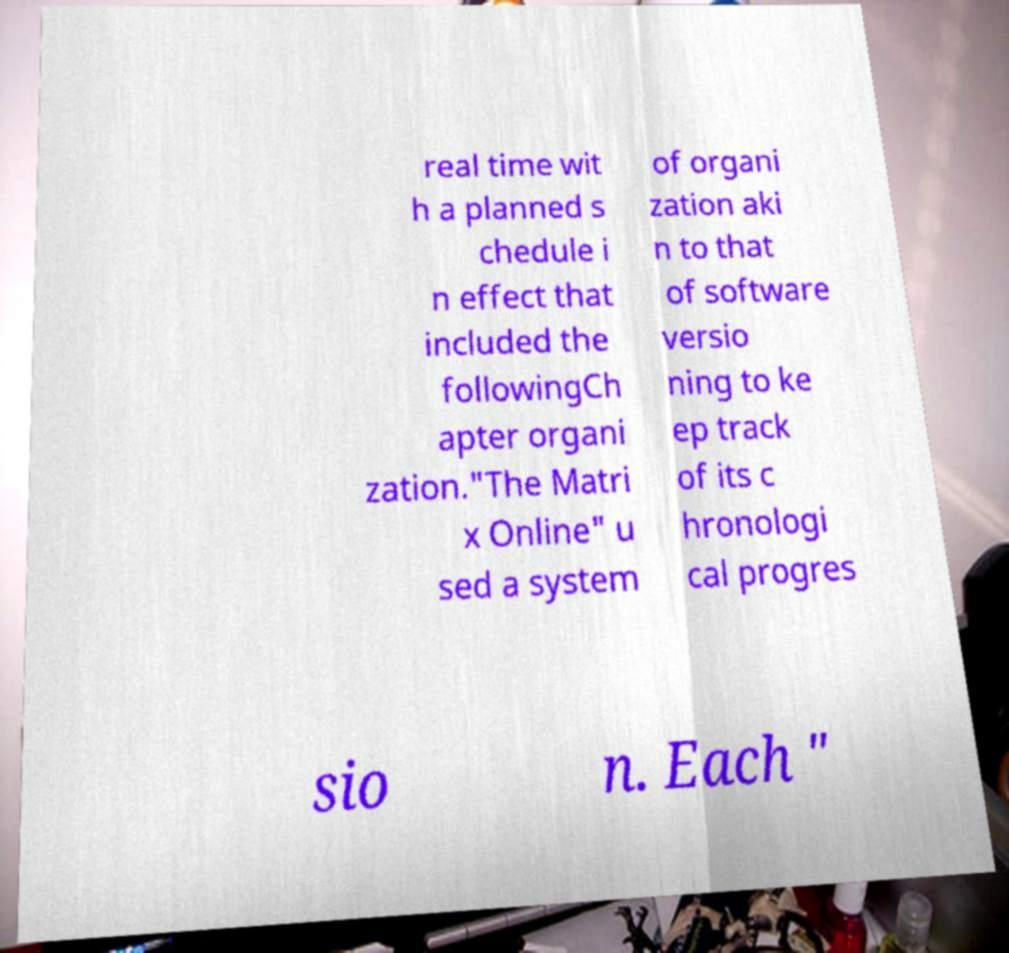Can you accurately transcribe the text from the provided image for me? real time wit h a planned s chedule i n effect that included the followingCh apter organi zation."The Matri x Online" u sed a system of organi zation aki n to that of software versio ning to ke ep track of its c hronologi cal progres sio n. Each " 